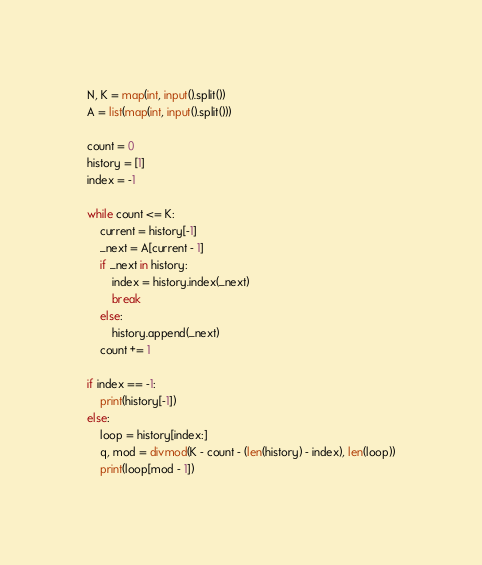<code> <loc_0><loc_0><loc_500><loc_500><_Python_>N, K = map(int, input().split())
A = list(map(int, input().split()))

count = 0
history = [1]
index = -1

while count <= K:
    current = history[-1]
    _next = A[current - 1]
    if _next in history:
        index = history.index(_next)
        break
    else:
        history.append(_next)
    count += 1

if index == -1:
    print(history[-1])
else:
    loop = history[index:]
    q, mod = divmod(K - count - (len(history) - index), len(loop))
    print(loop[mod - 1])
</code> 